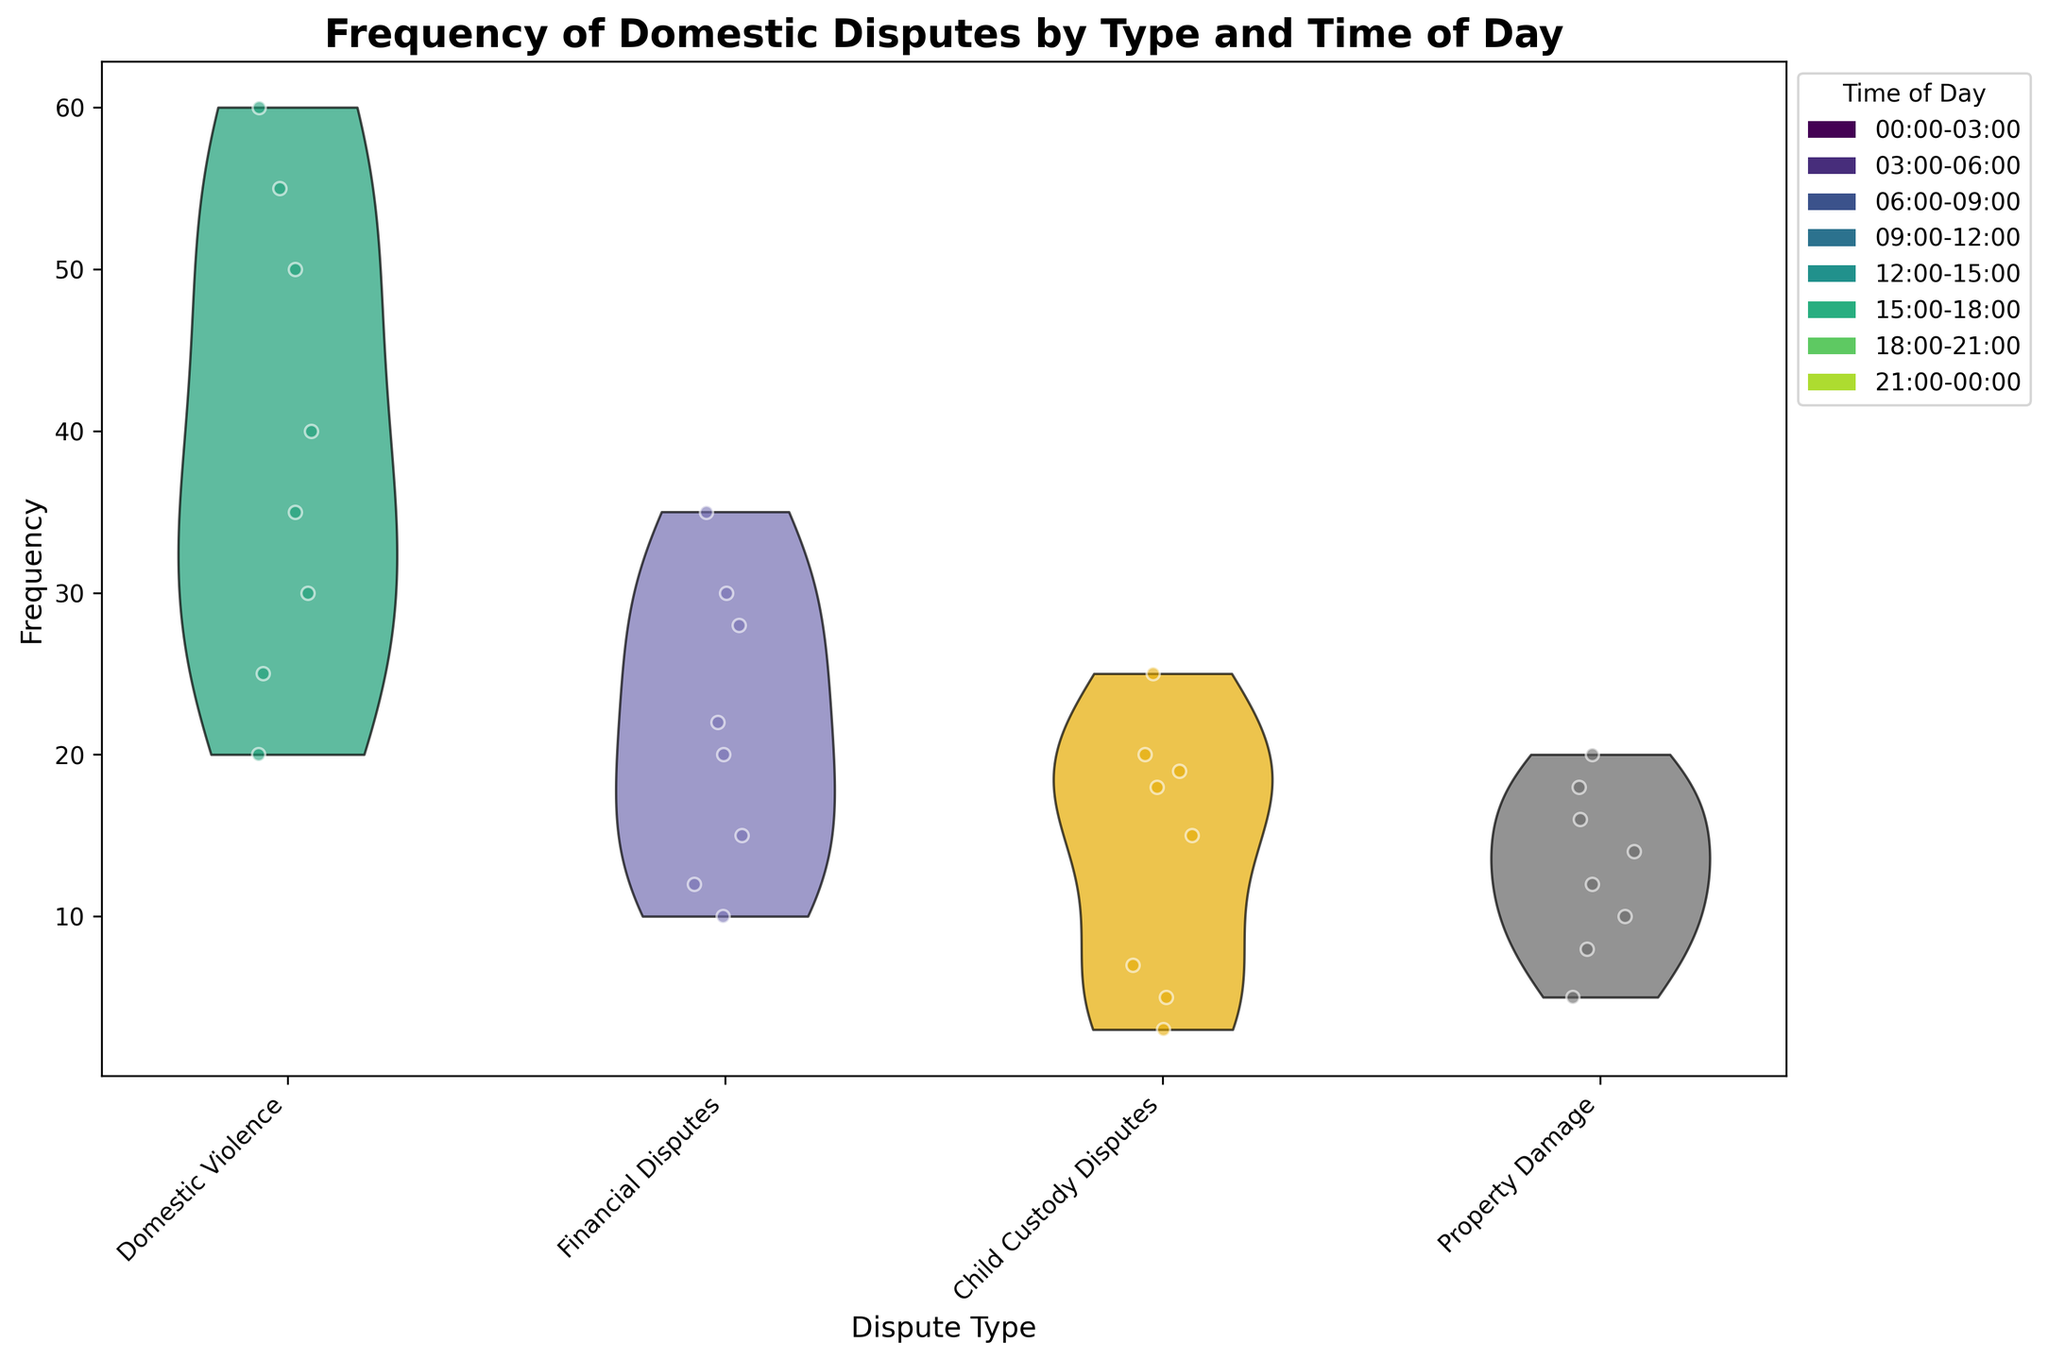What's the title of the figure? Look at the top of the plot. It’s usually where the title is displayed.
Answer: Frequency of Domestic Disputes by Type and Time of Day How many dispute types are represented in the figure? Check the number of unique categories on the X-axis, which shows dispute types.
Answer: 4 Which dispute type has the highest frequency during 15:00-18:00? Compare the height and density of the violins and scatter points for each dispute type for the 15:00-18:00 time slot.
Answer: Domestic Violence How does the frequency of Financial Disputes during 12:00-15:00 compare to 18:00-21:00? Compare the height and density of the violin plot segments for Financial Disputes at 12:00-15:00 and 18:00-21:00.
Answer: 18:00-21:00 has higher frequency What is the median frequency of Child Custody Disputes? Observe the densest part of the violin plot for Child Custody Disputes, as the median is in the middle of the data.
Answer: Around 15-18 Which time slot has the lowest frequency of Property Damage disputes? Identify the time slot where the violin plot for Property Damage is the least dense and closest to the X-axis.
Answer: 06:00-09:00 During which time of day are domestic disputes most frequent? Look for the time slot with the highest and densest violin plots across all dispute types.
Answer: 18:00-21:00 Compare the frequency of Domestic Violence during 03:00-06:00 and 21:00-00:00. Check the height and density of the violin plots for Domestic Violence at 03:00-06:00 and 21:00-00:00.
Answer: 21:00-00:00 has higher frequency What pattern do you observe in the frequency of Domestic Violence throughout the day? Look at the trend of Domestic Violence frequencies across different time slots.
Answer: Increases from 00:00 to 21:00, then slightly decreases at 21:00-00:00 Which dispute type shows the most variation in frequency across time slots? Compare the spread and density of the violin plots for each dispute type. The one with the widest range shows the most variation.
Answer: Domestic Violence 